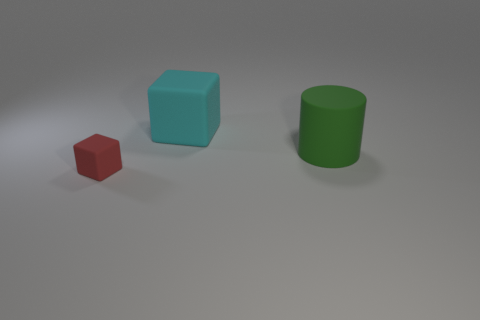Add 3 green spheres. How many objects exist? 6 Subtract all cylinders. How many objects are left? 2 Add 3 big cylinders. How many big cylinders are left? 4 Add 3 red rubber things. How many red rubber things exist? 4 Subtract 0 gray cylinders. How many objects are left? 3 Subtract all small green things. Subtract all cylinders. How many objects are left? 2 